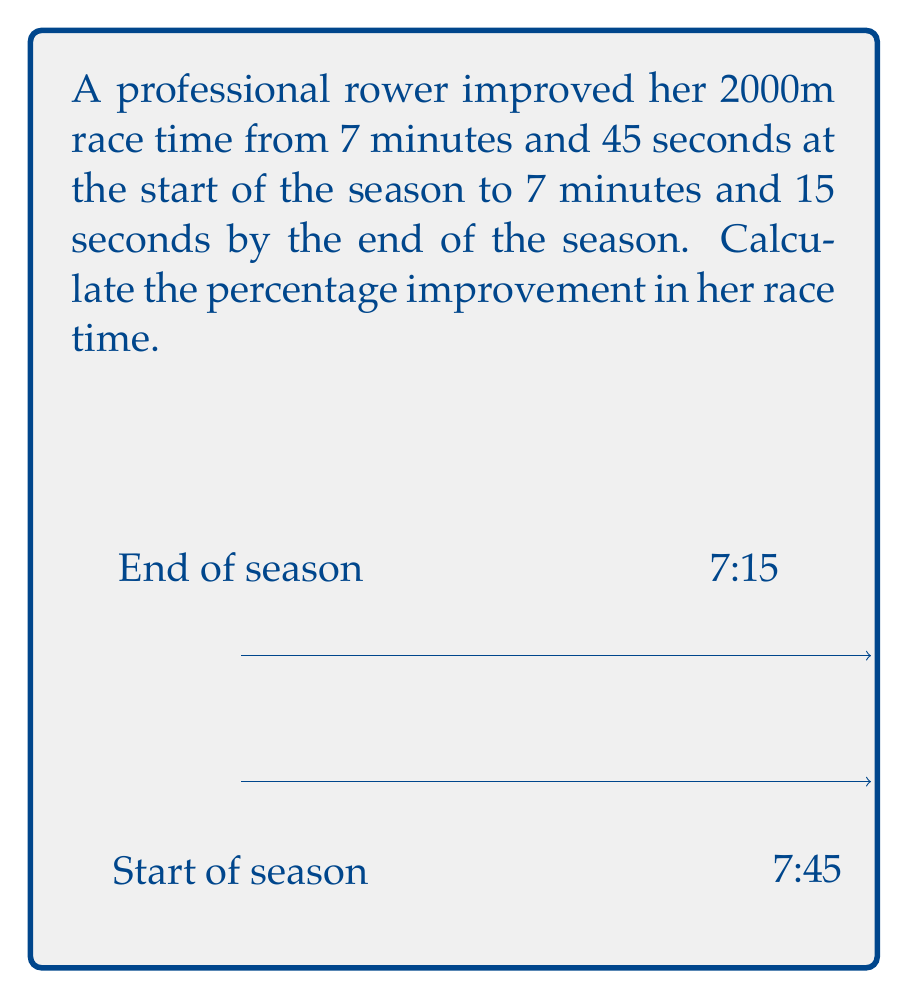Can you solve this math problem? Let's approach this step-by-step:

1) First, convert both times to seconds:
   Start time: $7 \text{ min } 45 \text{ sec} = (7 \times 60) + 45 = 465 \text{ seconds}$
   End time: $7 \text{ min } 15 \text{ sec} = (7 \times 60) + 15 = 435 \text{ seconds}$

2) Calculate the difference in time:
   $\text{Time improvement} = 465 - 435 = 30 \text{ seconds}$

3) To calculate the percentage improvement, use the formula:
   $$\text{Percentage improvement} = \frac{\text{Improvement}}{\text{Original time}} \times 100\%$$

4) Substitute the values:
   $$\text{Percentage improvement} = \frac{30}{465} \times 100\%$$

5) Simplify:
   $$\text{Percentage improvement} = 0.0645161 \times 100\% = 6.45161\%$$

6) Round to two decimal places:
   $$\text{Percentage improvement} \approx 6.45\%$$
Answer: 6.45% 